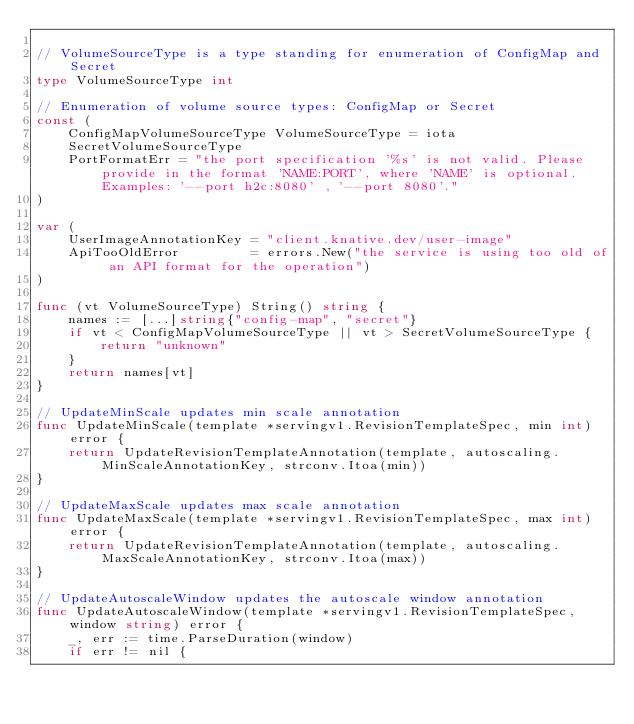<code> <loc_0><loc_0><loc_500><loc_500><_Go_>
// VolumeSourceType is a type standing for enumeration of ConfigMap and Secret
type VolumeSourceType int

// Enumeration of volume source types: ConfigMap or Secret
const (
	ConfigMapVolumeSourceType VolumeSourceType = iota
	SecretVolumeSourceType
	PortFormatErr = "the port specification '%s' is not valid. Please provide in the format 'NAME:PORT', where 'NAME' is optional. Examples: '--port h2c:8080' , '--port 8080'."
)

var (
	UserImageAnnotationKey = "client.knative.dev/user-image"
	ApiTooOldError         = errors.New("the service is using too old of an API format for the operation")
)

func (vt VolumeSourceType) String() string {
	names := [...]string{"config-map", "secret"}
	if vt < ConfigMapVolumeSourceType || vt > SecretVolumeSourceType {
		return "unknown"
	}
	return names[vt]
}

// UpdateMinScale updates min scale annotation
func UpdateMinScale(template *servingv1.RevisionTemplateSpec, min int) error {
	return UpdateRevisionTemplateAnnotation(template, autoscaling.MinScaleAnnotationKey, strconv.Itoa(min))
}

// UpdateMaxScale updates max scale annotation
func UpdateMaxScale(template *servingv1.RevisionTemplateSpec, max int) error {
	return UpdateRevisionTemplateAnnotation(template, autoscaling.MaxScaleAnnotationKey, strconv.Itoa(max))
}

// UpdateAutoscaleWindow updates the autoscale window annotation
func UpdateAutoscaleWindow(template *servingv1.RevisionTemplateSpec, window string) error {
	_, err := time.ParseDuration(window)
	if err != nil {</code> 